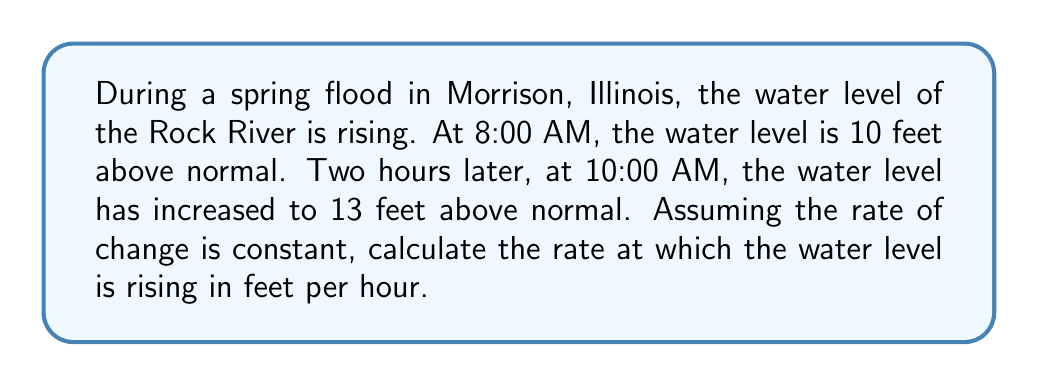Help me with this question. Let's approach this step-by-step:

1) We need to use the definition of the average rate of change:

   $$ \text{Rate of change} = \frac{\text{Change in y}}{\text{Change in x}} = \frac{\Delta y}{\Delta x} $$

2) In this case:
   - $\Delta y$ is the change in water level
   - $\Delta x$ is the change in time

3) Calculate $\Delta y$:
   $$ \Delta y = 13 \text{ feet} - 10 \text{ feet} = 3 \text{ feet} $$

4) Calculate $\Delta x$:
   $$ \Delta x = 10:00 \text{ AM} - 8:00 \text{ AM} = 2 \text{ hours} $$

5) Now, let's substitute these values into our rate of change formula:

   $$ \text{Rate of change} = \frac{\Delta y}{\Delta x} = \frac{3 \text{ feet}}{2 \text{ hours}} = 1.5 \text{ feet per hour} $$

Therefore, the water level of the Rock River is rising at a rate of 1.5 feet per hour.
Answer: $1.5 \text{ ft/hr}$ 